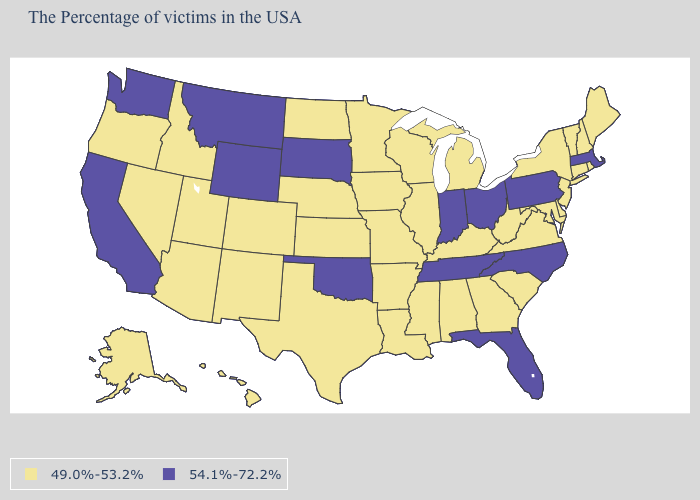What is the value of Colorado?
Quick response, please. 49.0%-53.2%. Name the states that have a value in the range 54.1%-72.2%?
Keep it brief. Massachusetts, Pennsylvania, North Carolina, Ohio, Florida, Indiana, Tennessee, Oklahoma, South Dakota, Wyoming, Montana, California, Washington. What is the value of Pennsylvania?
Keep it brief. 54.1%-72.2%. What is the value of Wyoming?
Concise answer only. 54.1%-72.2%. Name the states that have a value in the range 49.0%-53.2%?
Quick response, please. Maine, Rhode Island, New Hampshire, Vermont, Connecticut, New York, New Jersey, Delaware, Maryland, Virginia, South Carolina, West Virginia, Georgia, Michigan, Kentucky, Alabama, Wisconsin, Illinois, Mississippi, Louisiana, Missouri, Arkansas, Minnesota, Iowa, Kansas, Nebraska, Texas, North Dakota, Colorado, New Mexico, Utah, Arizona, Idaho, Nevada, Oregon, Alaska, Hawaii. Which states hav the highest value in the MidWest?
Write a very short answer. Ohio, Indiana, South Dakota. What is the highest value in the West ?
Give a very brief answer. 54.1%-72.2%. What is the value of New Hampshire?
Short answer required. 49.0%-53.2%. What is the value of Arizona?
Keep it brief. 49.0%-53.2%. What is the value of Maryland?
Keep it brief. 49.0%-53.2%. Does Alabama have the lowest value in the South?
Short answer required. Yes. Name the states that have a value in the range 49.0%-53.2%?
Write a very short answer. Maine, Rhode Island, New Hampshire, Vermont, Connecticut, New York, New Jersey, Delaware, Maryland, Virginia, South Carolina, West Virginia, Georgia, Michigan, Kentucky, Alabama, Wisconsin, Illinois, Mississippi, Louisiana, Missouri, Arkansas, Minnesota, Iowa, Kansas, Nebraska, Texas, North Dakota, Colorado, New Mexico, Utah, Arizona, Idaho, Nevada, Oregon, Alaska, Hawaii. Does Ohio have the lowest value in the USA?
Short answer required. No. What is the lowest value in the USA?
Quick response, please. 49.0%-53.2%. What is the value of Kentucky?
Keep it brief. 49.0%-53.2%. 